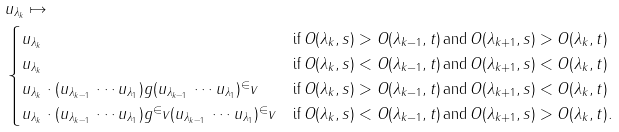Convert formula to latex. <formula><loc_0><loc_0><loc_500><loc_500>& u _ { \lambda _ { k } } \mapsto \\ & \begin{cases} u _ { \lambda _ { k } } & \text {if} \, O ( \lambda _ { k } , s ) > O ( \lambda _ { k - 1 } , t ) \, \text {and} \, O ( \lambda _ { k + 1 } , s ) > O ( \lambda _ { k } , t ) \\ u _ { \lambda _ { k } } & \text {if} \, O ( \lambda _ { k } , s ) < O ( \lambda _ { k - 1 } , t ) \, \text {and} \, O ( \lambda _ { k + 1 } , s ) < O ( \lambda _ { k } , t ) \\ u _ { \lambda _ { k } } \cdot ( u _ { \lambda _ { k - 1 } } \, \cdots u _ { \lambda _ { 1 } } ) g ( u _ { \lambda _ { k - 1 } } \, \cdots u _ { \lambda _ { 1 } } ) ^ { \in } v & \text {if} \, O ( \lambda _ { k } , s ) > O ( \lambda _ { k - 1 } , t ) \, \text {and} \, O ( \lambda _ { k + 1 } , s ) < O ( \lambda _ { k } , t ) \\ u _ { \lambda _ { k } } \cdot ( u _ { \lambda _ { k - 1 } } \, \cdots u _ { \lambda _ { 1 } } ) g ^ { \in } v ( u _ { \lambda _ { k - 1 } } \, \cdots u _ { \lambda _ { 1 } } ) ^ { \in } v & \text {if} \, O ( \lambda _ { k } , s ) < O ( \lambda _ { k - 1 } , t ) \, \text {and} \, O ( \lambda _ { k + 1 } , s ) > O ( \lambda _ { k } , t ) . \end{cases}</formula> 